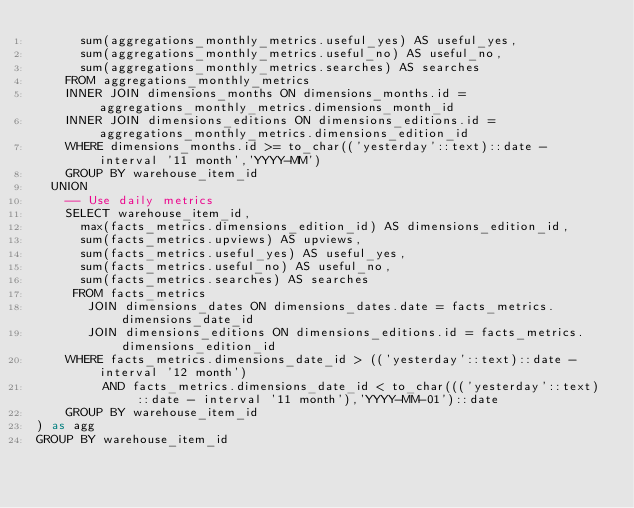<code> <loc_0><loc_0><loc_500><loc_500><_SQL_>      sum(aggregations_monthly_metrics.useful_yes) AS useful_yes,
      sum(aggregations_monthly_metrics.useful_no) AS useful_no,
      sum(aggregations_monthly_metrics.searches) AS searches
    FROM aggregations_monthly_metrics
    INNER JOIN dimensions_months ON dimensions_months.id = aggregations_monthly_metrics.dimensions_month_id
    INNER JOIN dimensions_editions ON dimensions_editions.id = aggregations_monthly_metrics.dimensions_edition_id
    WHERE dimensions_months.id >= to_char(('yesterday'::text)::date - interval '11 month','YYYY-MM')
    GROUP BY warehouse_item_id
  UNION
    -- Use daily metrics
    SELECT warehouse_item_id,
      max(facts_metrics.dimensions_edition_id) AS dimensions_edition_id,
      sum(facts_metrics.upviews) AS upviews,
      sum(facts_metrics.useful_yes) AS useful_yes,
      sum(facts_metrics.useful_no) AS useful_no,
      sum(facts_metrics.searches) AS searches
     FROM facts_metrics
       JOIN dimensions_dates ON dimensions_dates.date = facts_metrics.dimensions_date_id
       JOIN dimensions_editions ON dimensions_editions.id = facts_metrics.dimensions_edition_id
    WHERE facts_metrics.dimensions_date_id > (('yesterday'::text)::date - interval '12 month')
         AND facts_metrics.dimensions_date_id < to_char((('yesterday'::text)::date - interval '11 month'),'YYYY-MM-01')::date
    GROUP BY warehouse_item_id
) as agg
GROUP BY warehouse_item_id
</code> 